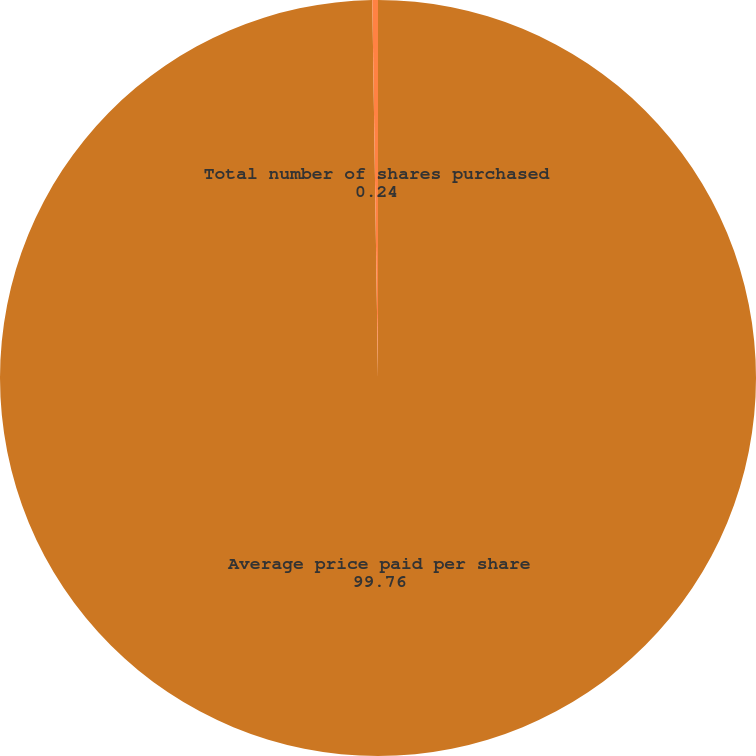Convert chart to OTSL. <chart><loc_0><loc_0><loc_500><loc_500><pie_chart><fcel>Average price paid per share<fcel>Total number of shares purchased<nl><fcel>99.76%<fcel>0.24%<nl></chart> 